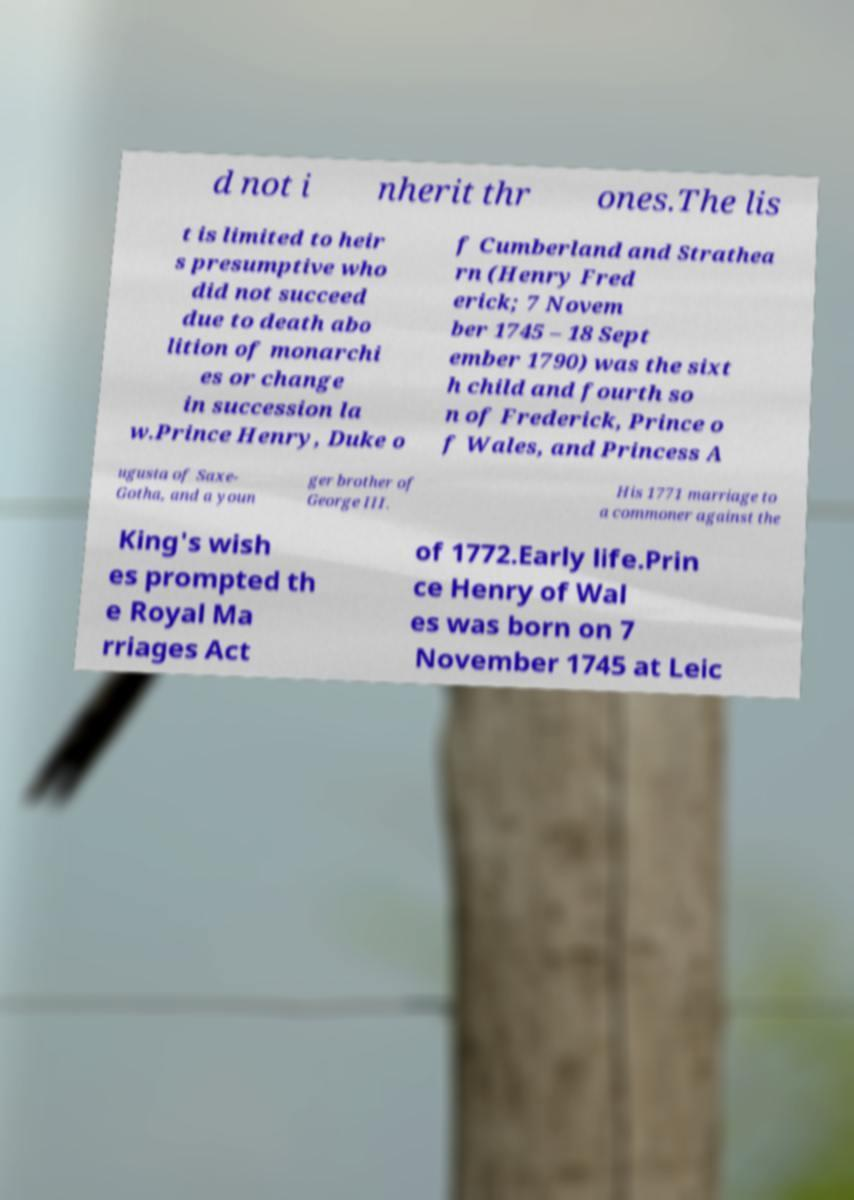What messages or text are displayed in this image? I need them in a readable, typed format. d not i nherit thr ones.The lis t is limited to heir s presumptive who did not succeed due to death abo lition of monarchi es or change in succession la w.Prince Henry, Duke o f Cumberland and Strathea rn (Henry Fred erick; 7 Novem ber 1745 – 18 Sept ember 1790) was the sixt h child and fourth so n of Frederick, Prince o f Wales, and Princess A ugusta of Saxe- Gotha, and a youn ger brother of George III. His 1771 marriage to a commoner against the King's wish es prompted th e Royal Ma rriages Act of 1772.Early life.Prin ce Henry of Wal es was born on 7 November 1745 at Leic 